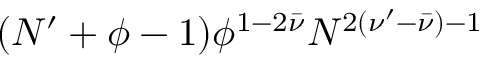<formula> <loc_0><loc_0><loc_500><loc_500>( N ^ { \prime } + \phi - 1 ) \phi ^ { 1 - 2 \bar { \nu } } N ^ { 2 ( \nu ^ { \prime } - \bar { \nu } ) - 1 }</formula> 